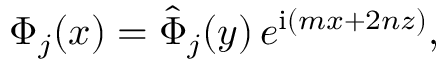Convert formula to latex. <formula><loc_0><loc_0><loc_500><loc_500>\Phi _ { j } ( x ) = \hat { \Phi } _ { j } ( y ) \, e ^ { i ( m x + 2 n z ) } ,</formula> 